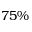Convert formula to latex. <formula><loc_0><loc_0><loc_500><loc_500>7 5 \%</formula> 